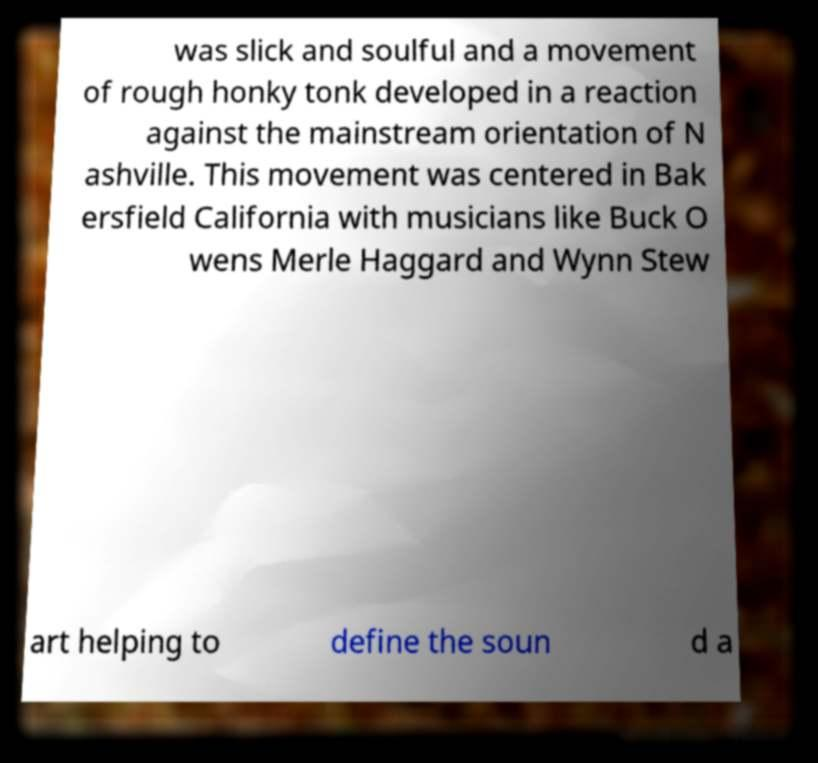There's text embedded in this image that I need extracted. Can you transcribe it verbatim? was slick and soulful and a movement of rough honky tonk developed in a reaction against the mainstream orientation of N ashville. This movement was centered in Bak ersfield California with musicians like Buck O wens Merle Haggard and Wynn Stew art helping to define the soun d a 